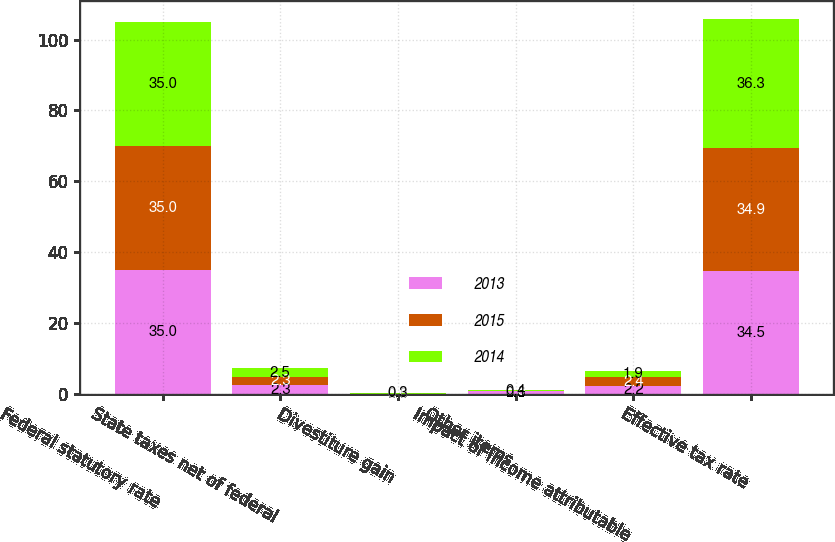Convert chart. <chart><loc_0><loc_0><loc_500><loc_500><stacked_bar_chart><ecel><fcel>Federal statutory rate<fcel>State taxes net of federal<fcel>Divestiture gain<fcel>Other items<fcel>Impact of income attributable<fcel>Effective tax rate<nl><fcel>2013<fcel>35<fcel>2.3<fcel>0<fcel>0.6<fcel>2.2<fcel>34.5<nl><fcel>2015<fcel>35<fcel>2.3<fcel>0<fcel>0<fcel>2.4<fcel>34.9<nl><fcel>2014<fcel>35<fcel>2.5<fcel>0.3<fcel>0.4<fcel>1.9<fcel>36.3<nl></chart> 